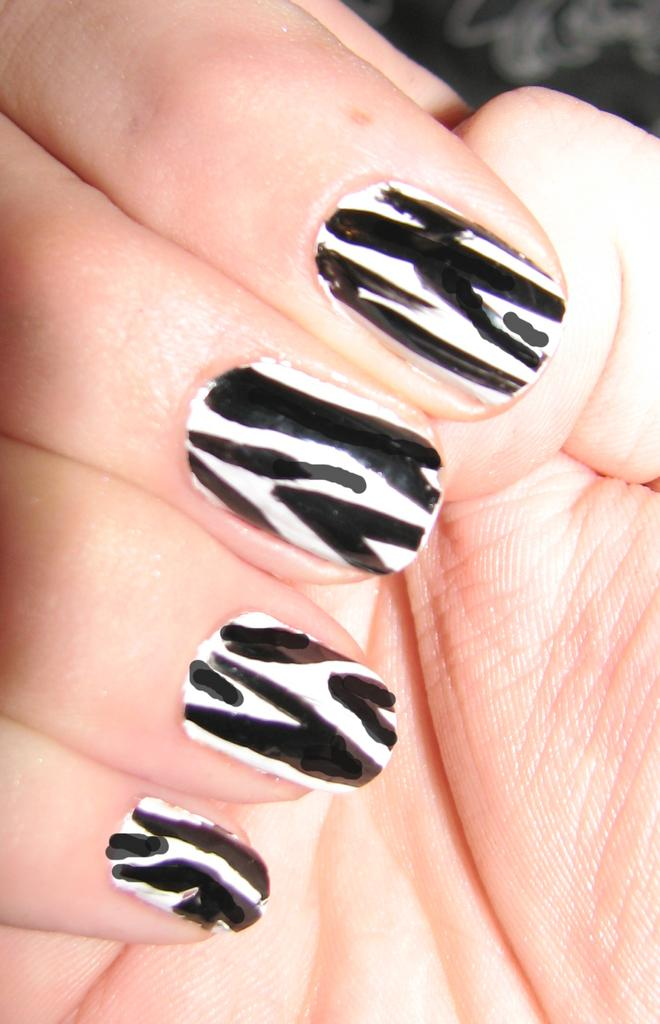What part of a person's body is visible in the foreground of the image? There is a person's hand visible in the foreground of the image. What can be observed about the person's nails in the image? The person's nails have nail paint. What type of tank can be seen in the background of the image? There is no tank visible in the image; only a person's hand with painted nails is present. 